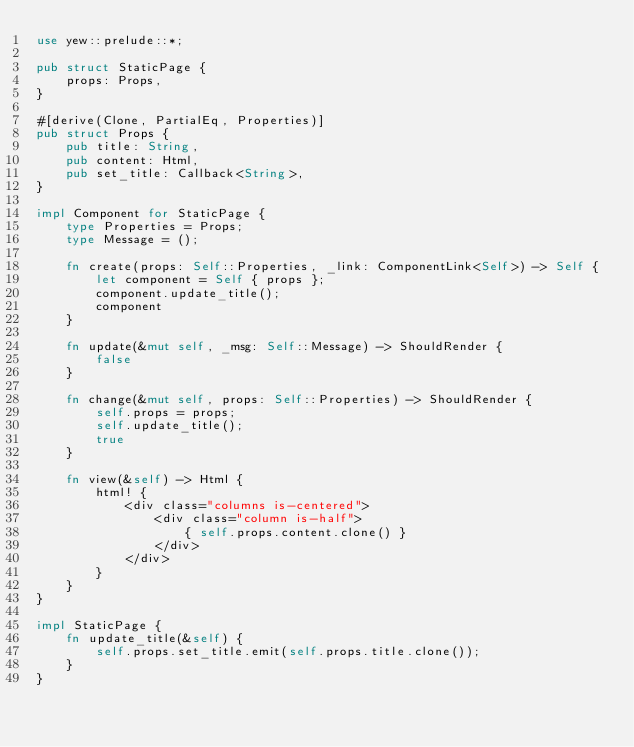<code> <loc_0><loc_0><loc_500><loc_500><_Rust_>use yew::prelude::*;

pub struct StaticPage {
    props: Props,
}

#[derive(Clone, PartialEq, Properties)]
pub struct Props {
    pub title: String,
    pub content: Html,
    pub set_title: Callback<String>,
}

impl Component for StaticPage {
    type Properties = Props;
    type Message = ();

    fn create(props: Self::Properties, _link: ComponentLink<Self>) -> Self {
        let component = Self { props };
        component.update_title();
        component
    }

    fn update(&mut self, _msg: Self::Message) -> ShouldRender {
        false
    }

    fn change(&mut self, props: Self::Properties) -> ShouldRender {
        self.props = props;
        self.update_title();
        true
    }

    fn view(&self) -> Html {
        html! {
            <div class="columns is-centered">
                <div class="column is-half">
                    { self.props.content.clone() }
                </div>
            </div>
        }
    }
}

impl StaticPage {
    fn update_title(&self) {
        self.props.set_title.emit(self.props.title.clone());
    }
}
</code> 